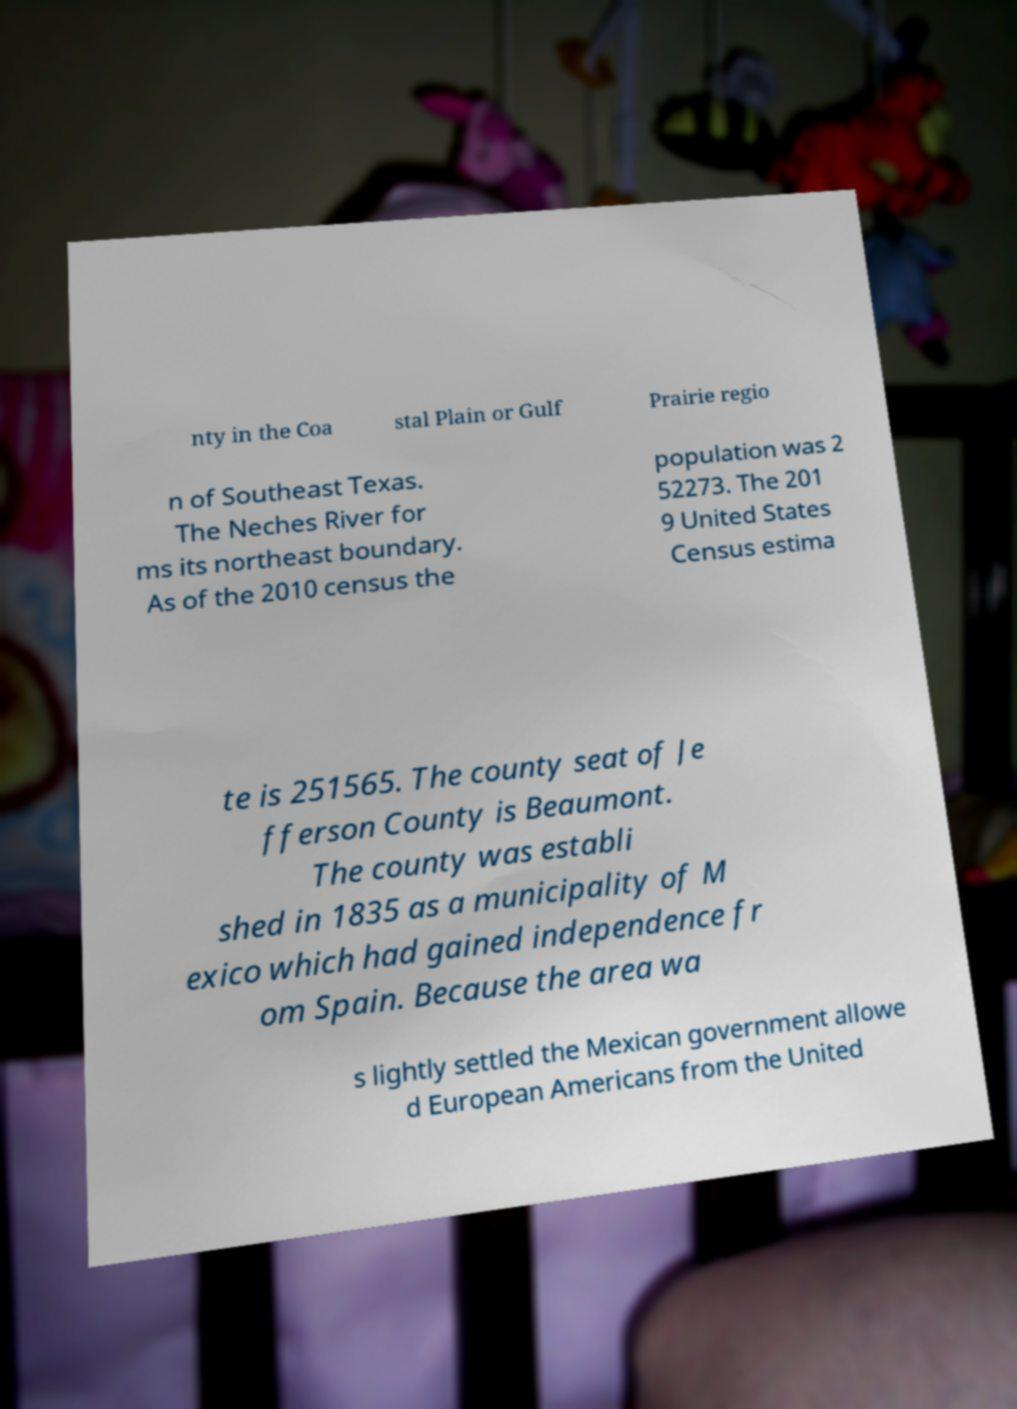Can you read and provide the text displayed in the image?This photo seems to have some interesting text. Can you extract and type it out for me? nty in the Coa stal Plain or Gulf Prairie regio n of Southeast Texas. The Neches River for ms its northeast boundary. As of the 2010 census the population was 2 52273. The 201 9 United States Census estima te is 251565. The county seat of Je fferson County is Beaumont. The county was establi shed in 1835 as a municipality of M exico which had gained independence fr om Spain. Because the area wa s lightly settled the Mexican government allowe d European Americans from the United 